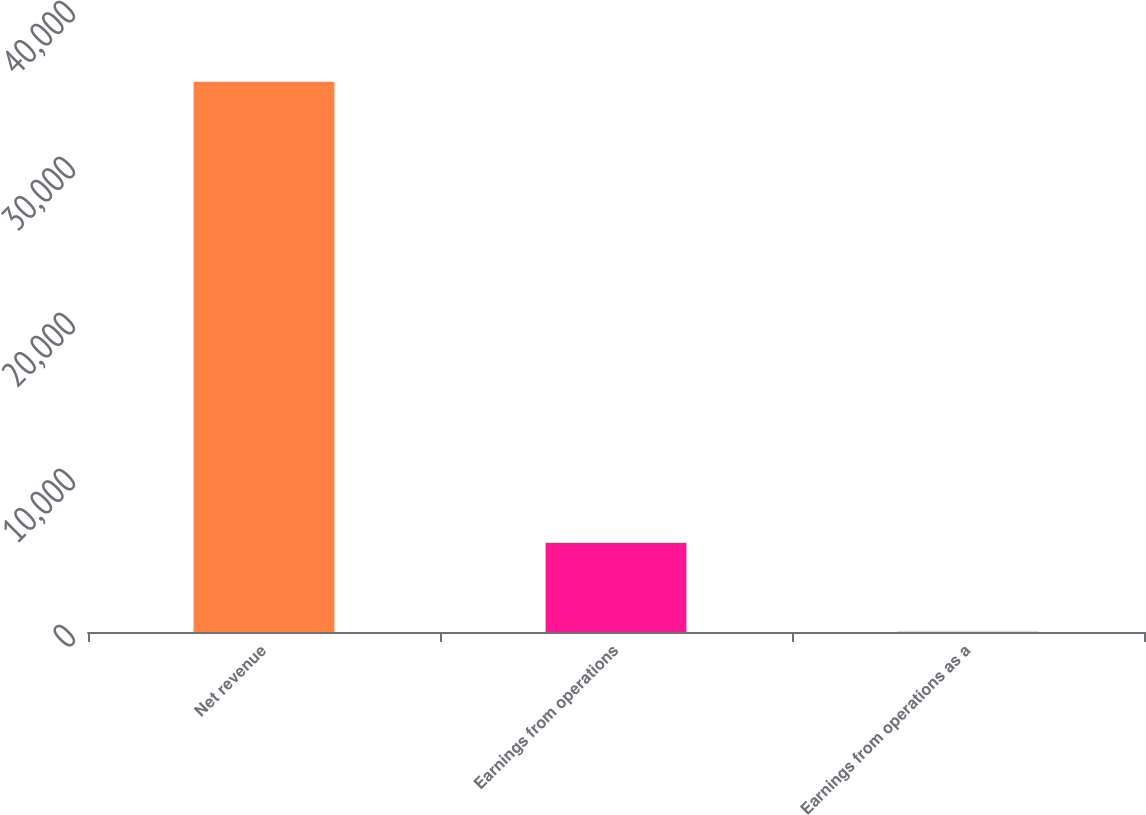Convert chart. <chart><loc_0><loc_0><loc_500><loc_500><bar_chart><fcel>Net revenue<fcel>Earnings from operations<fcel>Earnings from operations as a<nl><fcel>35276<fcel>5714<fcel>16.2<nl></chart> 